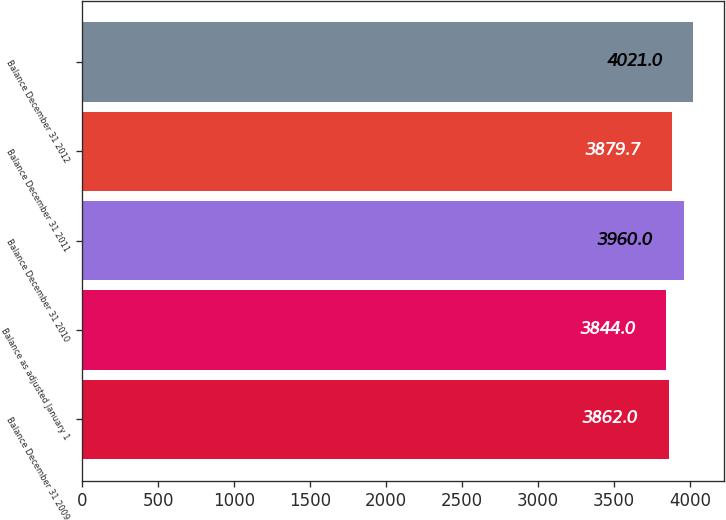Convert chart. <chart><loc_0><loc_0><loc_500><loc_500><bar_chart><fcel>Balance December 31 2009<fcel>Balance as adjusted January 1<fcel>Balance December 31 2010<fcel>Balance December 31 2011<fcel>Balance December 31 2012<nl><fcel>3862<fcel>3844<fcel>3960<fcel>3879.7<fcel>4021<nl></chart> 